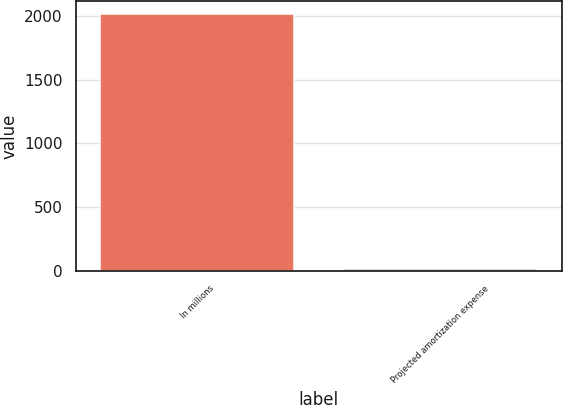Convert chart to OTSL. <chart><loc_0><loc_0><loc_500><loc_500><bar_chart><fcel>In millions<fcel>Projected amortization expense<nl><fcel>2014<fcel>13<nl></chart> 